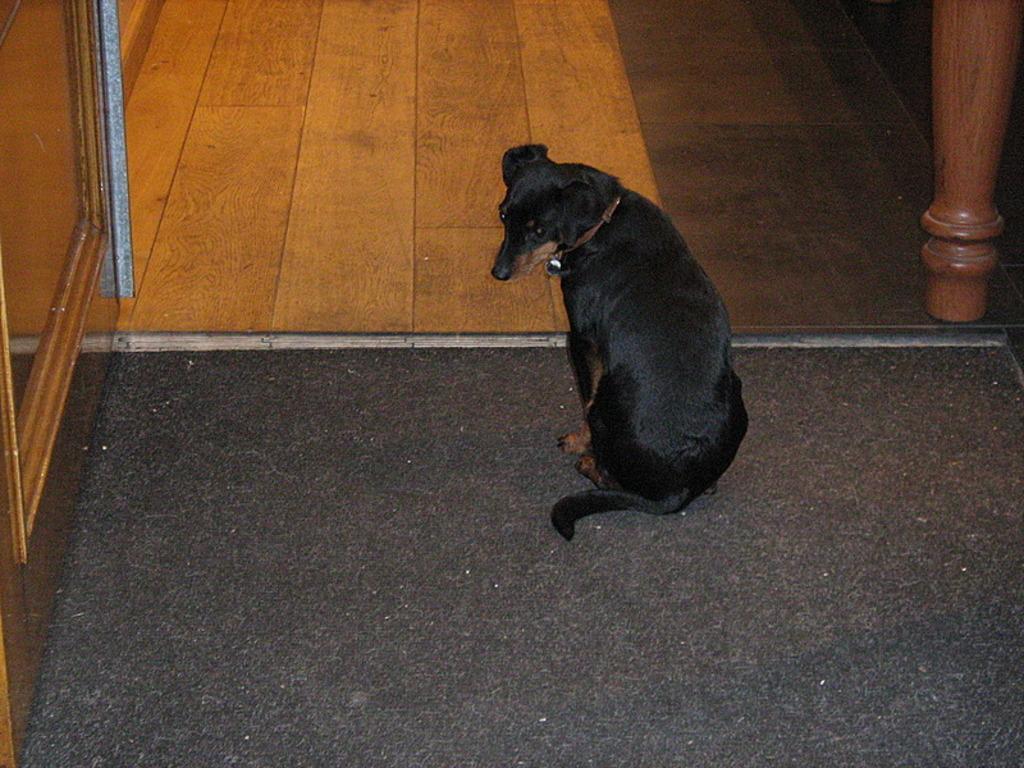Describe this image in one or two sentences. It's a dog which is in black color. 